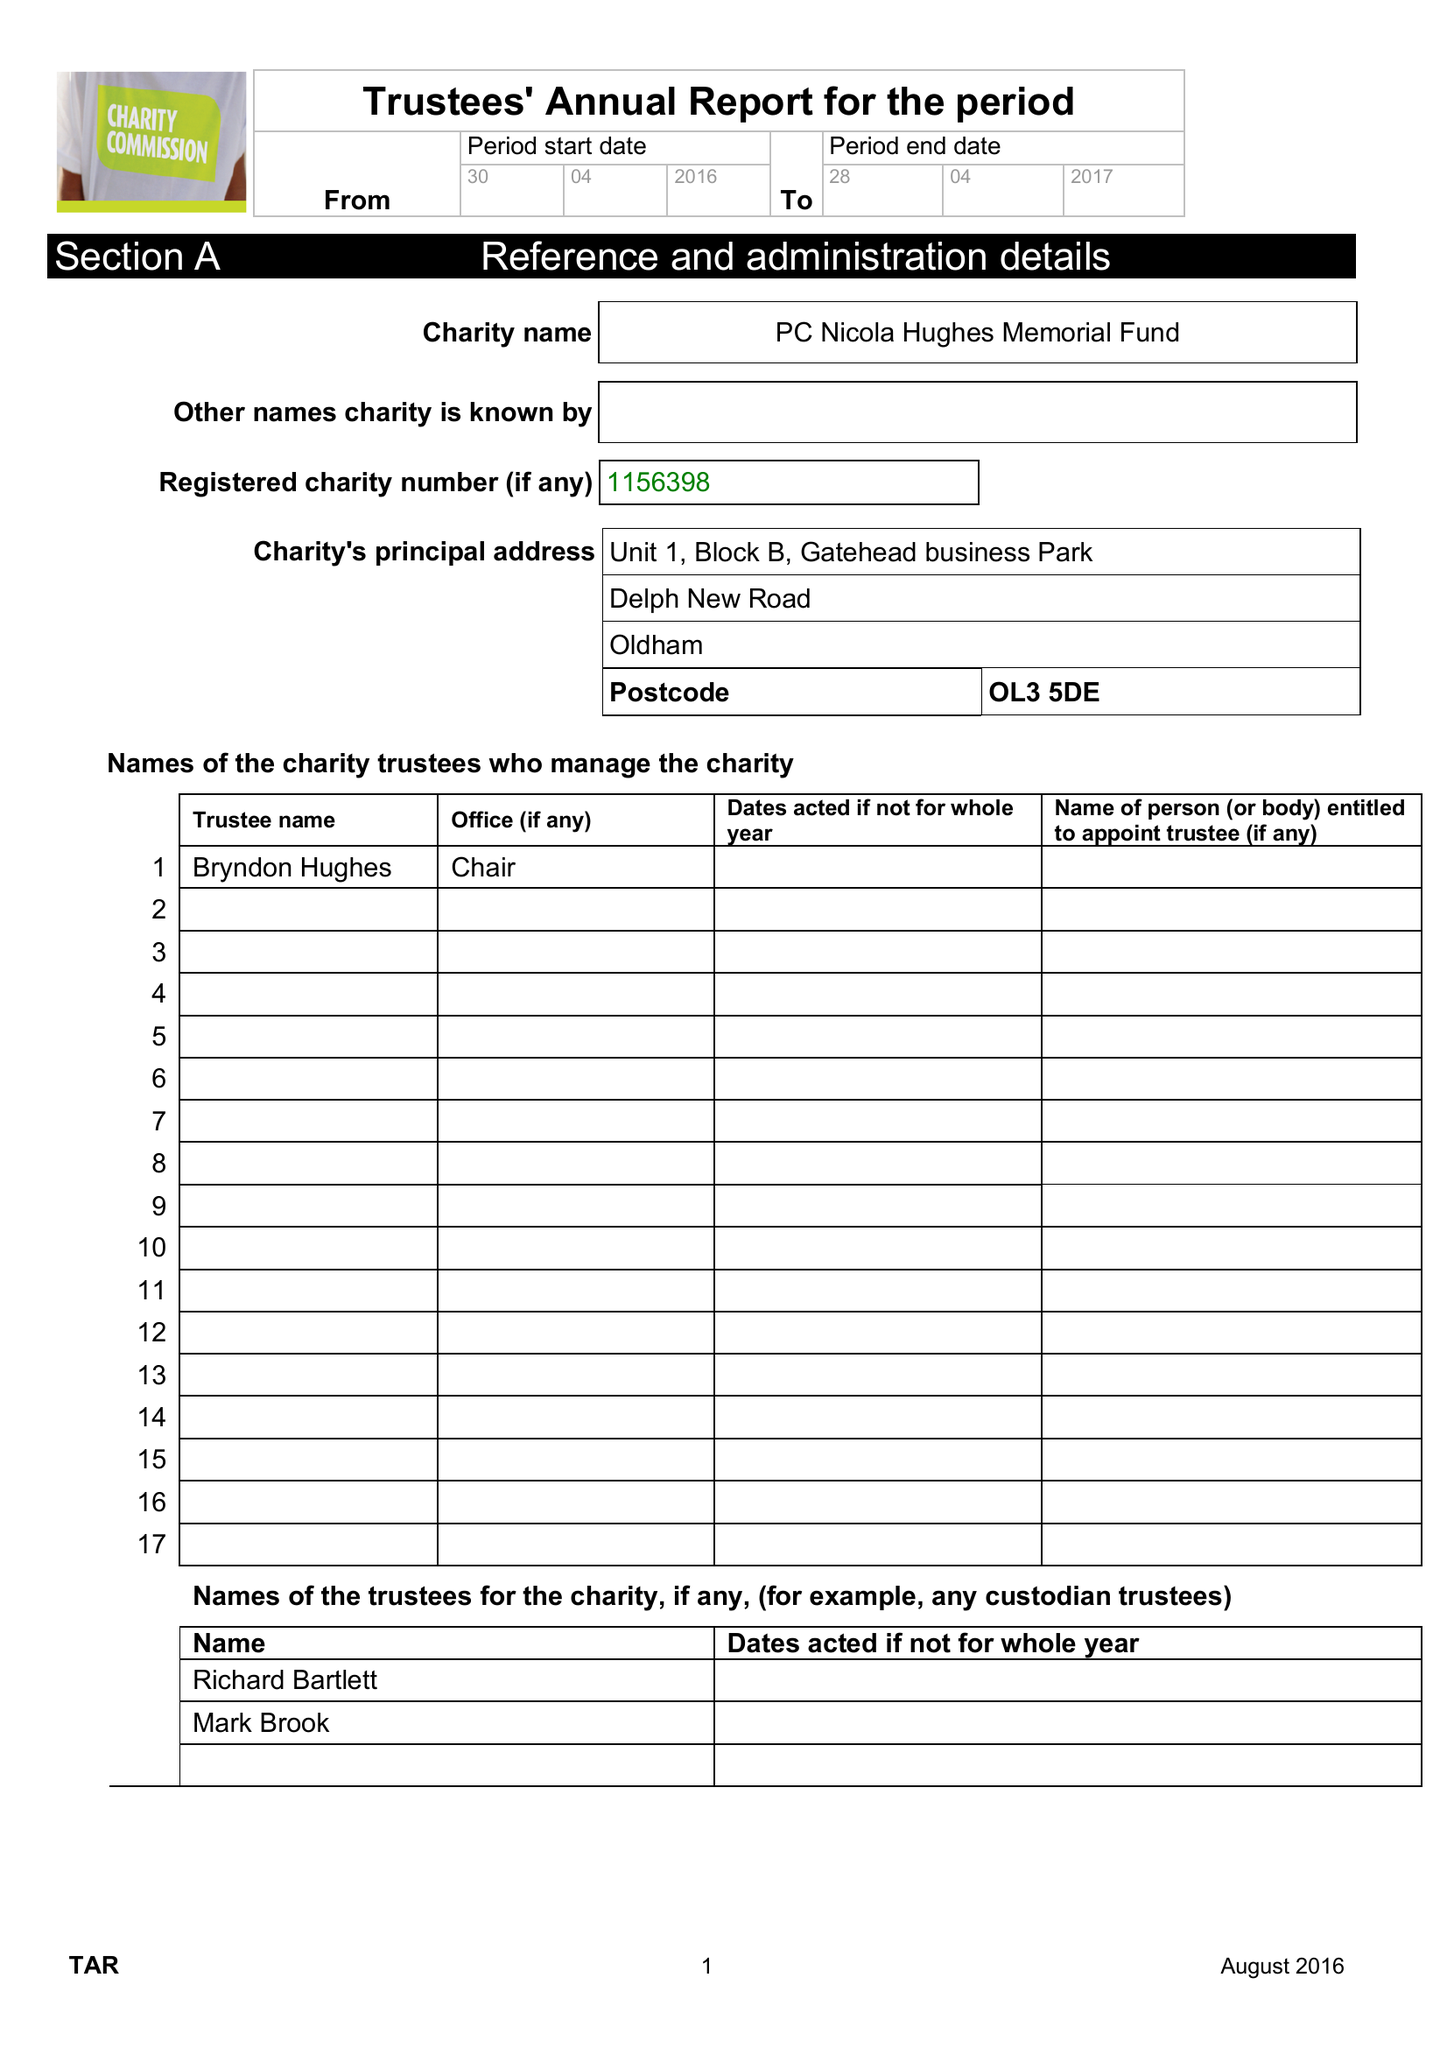What is the value for the spending_annually_in_british_pounds?
Answer the question using a single word or phrase. 43497.00 